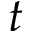<formula> <loc_0><loc_0><loc_500><loc_500>t</formula> 